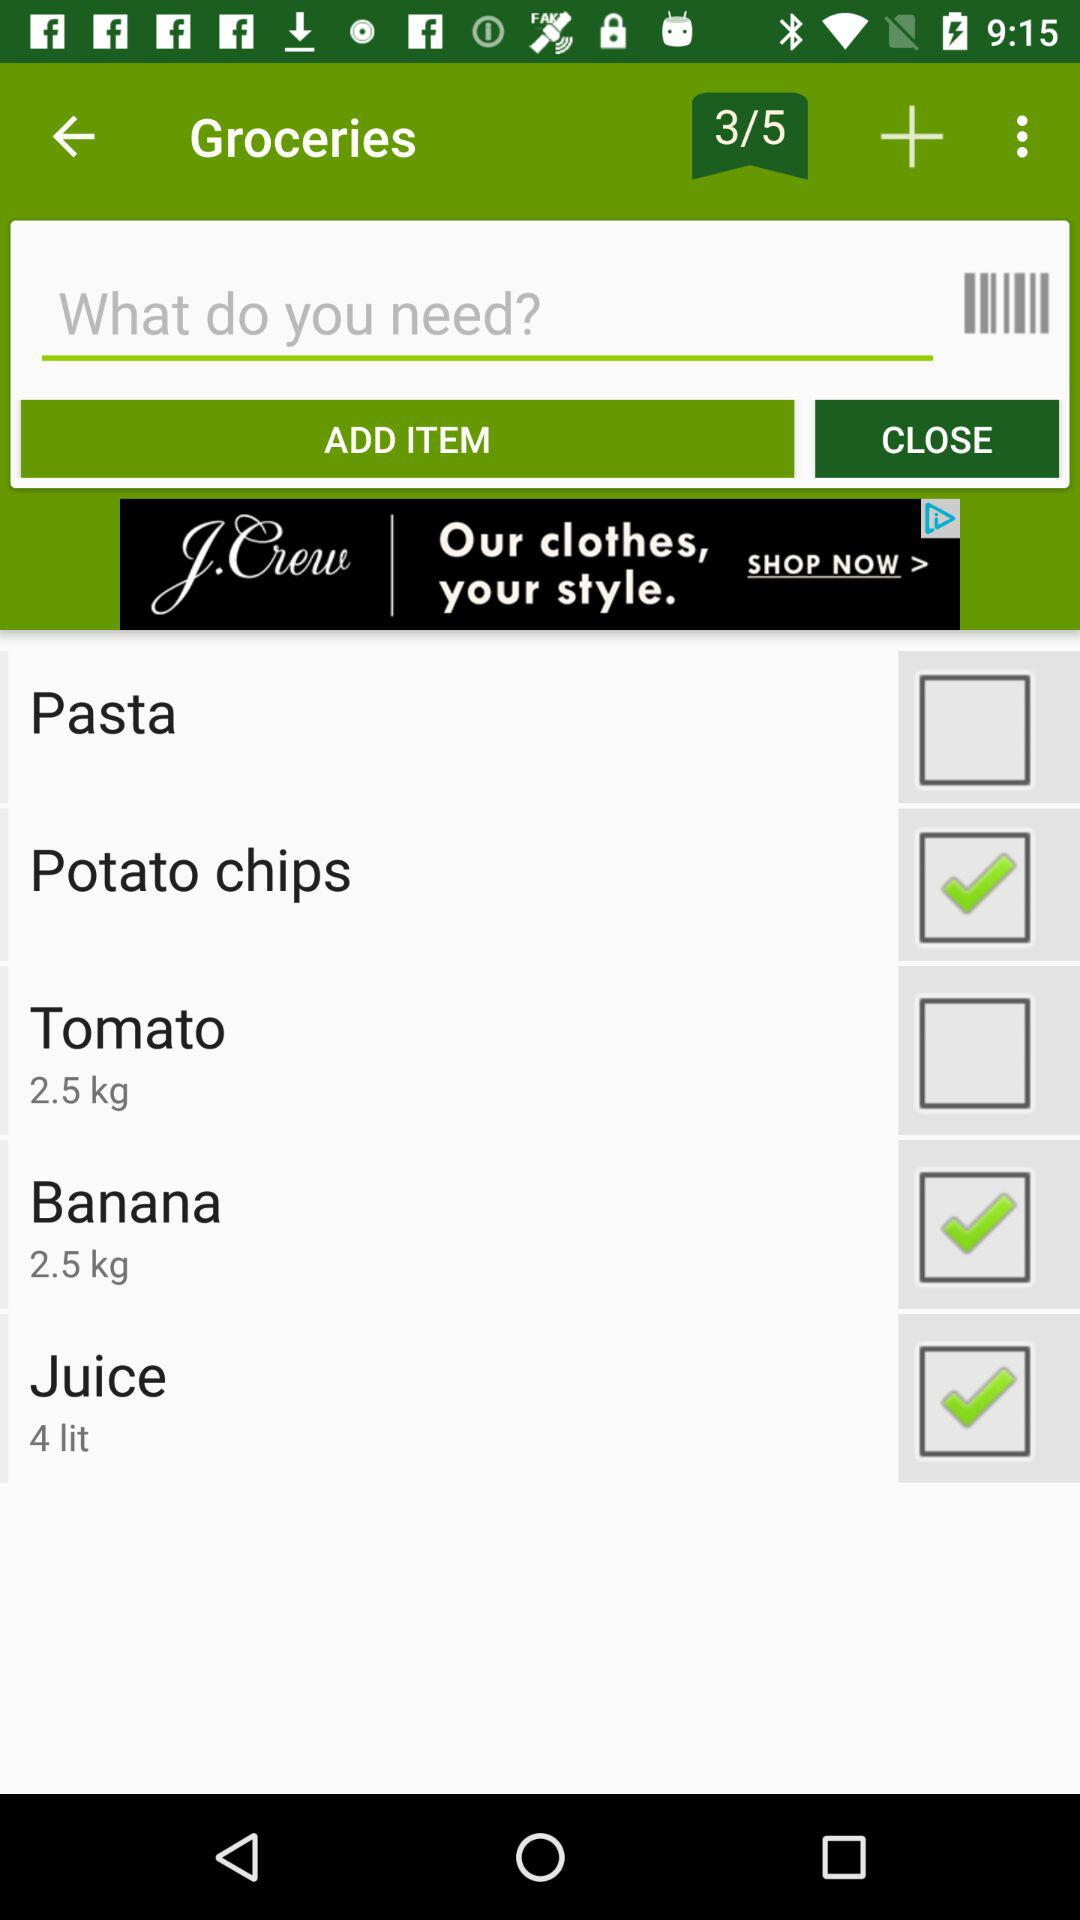How many items in total are there to select from? There are 5 items to select from. 